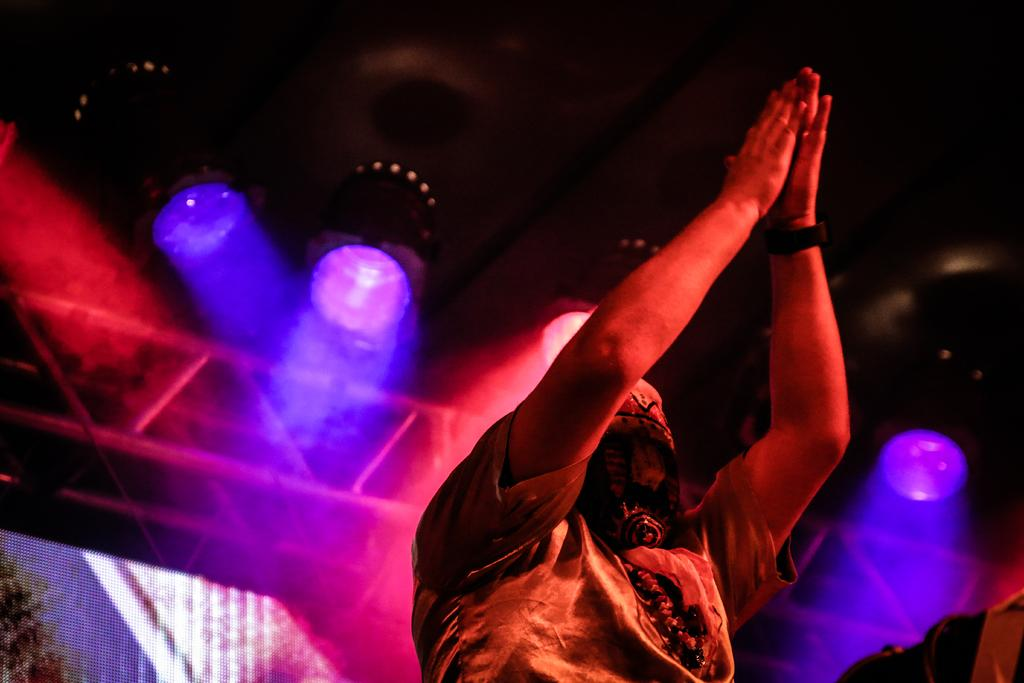Who or what is in the center of the image? There is a person in the center of the image. What can be seen at the top of the image? There are lights at the top of the image. What objects are present in the image that resemble long, thin bars? There are rods in the image. Where is the screen located in the image? The screen is at the left side bottom of the image. What type of mint is growing on the person's head in the image? There is no mint growing on the person's head in the image. How low is the person sitting in the image? The image does not provide information about the person's sitting position or height. Can you tell me if the person in the image is about to sneeze? There is no indication in the image that the person is about to sneeze. 